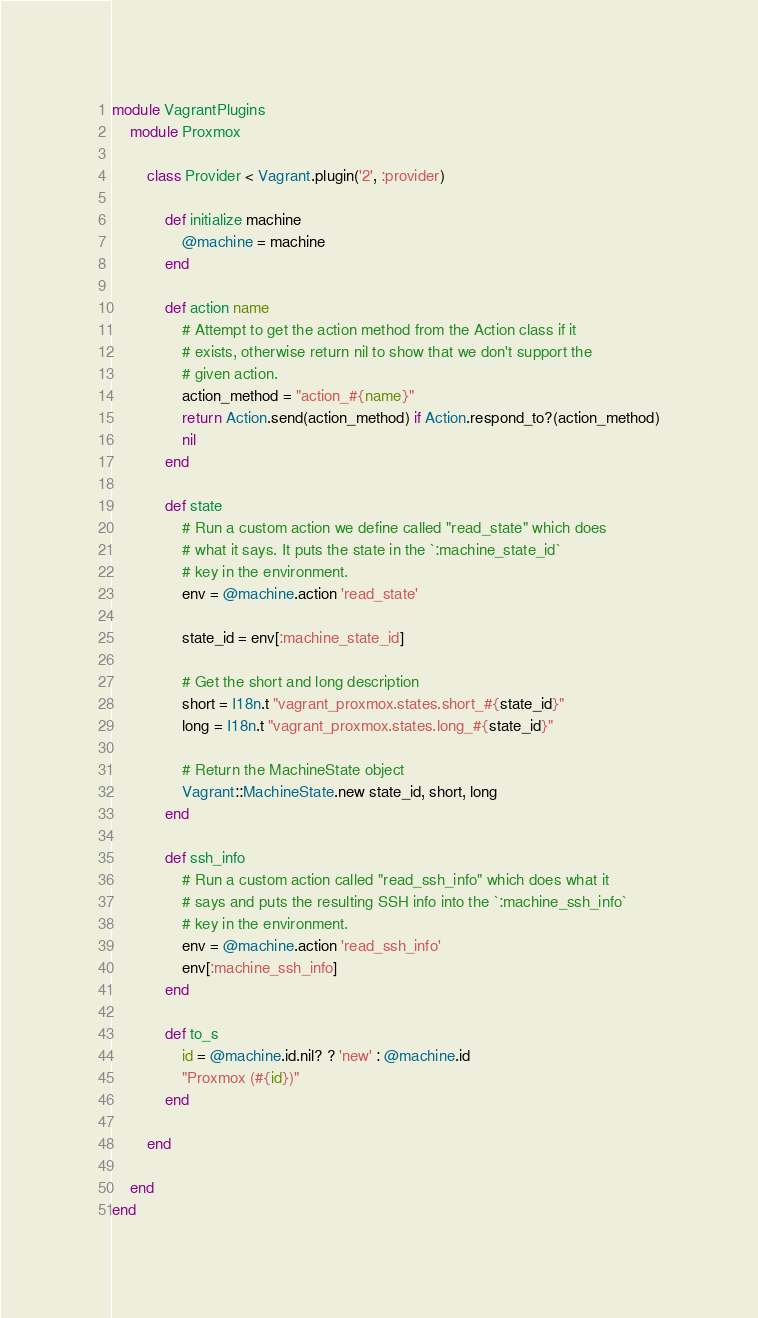<code> <loc_0><loc_0><loc_500><loc_500><_Ruby_>module VagrantPlugins
	module Proxmox

		class Provider < Vagrant.plugin('2', :provider)

			def initialize machine
				@machine = machine
			end

			def action name
				# Attempt to get the action method from the Action class if it
				# exists, otherwise return nil to show that we don't support the
				# given action.
				action_method = "action_#{name}"
				return Action.send(action_method) if Action.respond_to?(action_method)
				nil
			end

			def state
				# Run a custom action we define called "read_state" which does
				# what it says. It puts the state in the `:machine_state_id`
				# key in the environment.
				env = @machine.action 'read_state'

				state_id = env[:machine_state_id]

				# Get the short and long description
				short = I18n.t "vagrant_proxmox.states.short_#{state_id}"
				long = I18n.t "vagrant_proxmox.states.long_#{state_id}"

				# Return the MachineState object
				Vagrant::MachineState.new state_id, short, long
			end

			def ssh_info
				# Run a custom action called "read_ssh_info" which does what it
				# says and puts the resulting SSH info into the `:machine_ssh_info`
				# key in the environment.
				env = @machine.action 'read_ssh_info'
				env[:machine_ssh_info]
			end

			def to_s
				id = @machine.id.nil? ? 'new' : @machine.id
				"Proxmox (#{id})"
			end

		end

	end
end
</code> 